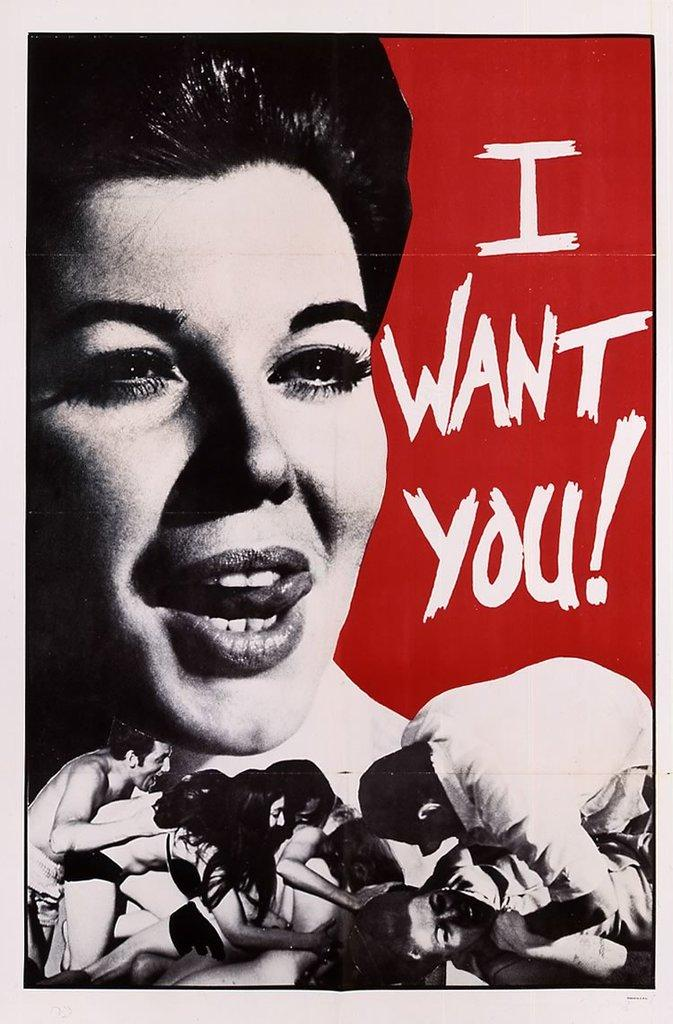<image>
Offer a succinct explanation of the picture presented. Poster that shows a woman licking her lips and saying "I Want You". 